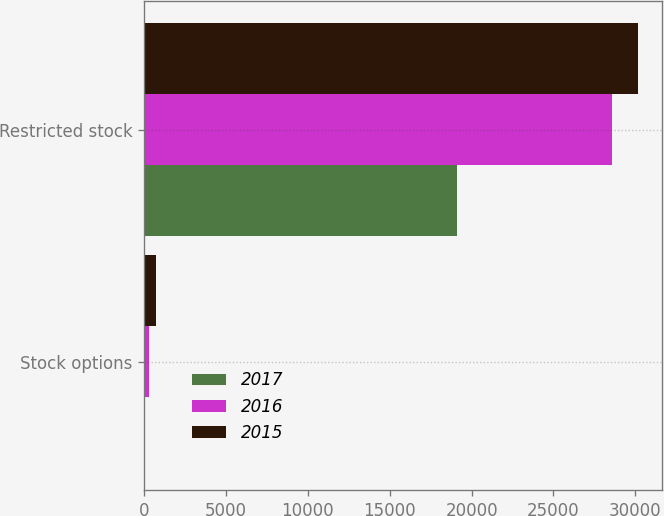Convert chart. <chart><loc_0><loc_0><loc_500><loc_500><stacked_bar_chart><ecel><fcel>Stock options<fcel>Restricted stock<nl><fcel>2017<fcel>10<fcel>19092<nl><fcel>2016<fcel>266<fcel>28603<nl><fcel>2015<fcel>698<fcel>30146<nl></chart> 